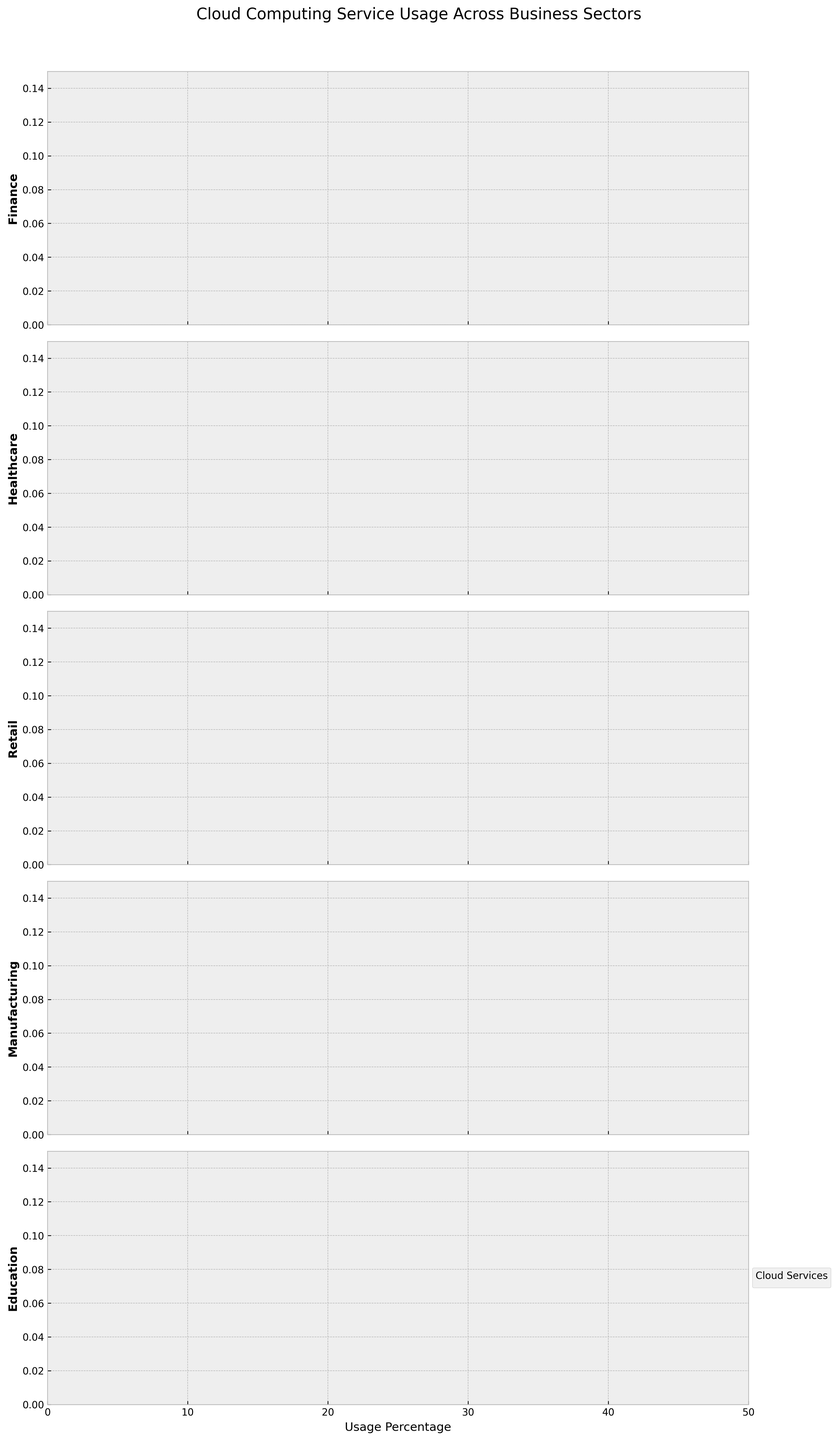What is the title of the figure? The title of the figure is written at the top, which provides an overview of what the figure is about. According to the data and code, the title should be "Cloud Computing Service Usage Across Business Sectors."
Answer: Cloud Computing Service Usage Across Business Sectors Which sector shows the highest usage percentage for Azure? By comparing the density plots across the sectors, the highest peak of Azure's usage percentage can be observed. The Education sector has the highest Azure usage at 35.6%.
Answer: Education Which cloud service has the lowest usage percentage in the Retail sector? By examining the density plots for the Retail sector, the cloud service with the lowest peak or distribution will be the least used. Oracle Cloud has the lowest usage percentage at 4.9%.
Answer: Oracle Cloud Is AWS usage generally higher in the Retail sector than in the Healthcare sector? Compare the density plots of AWS for both sectors. The peak and overall distribution for Retail are higher than Healthcare.
Answer: Yes What is the range of usage percentages displayed on the x-axis? The x-axis range can be determined by observing the limits set by the plots. From the provided code, the x-axis is limited from 0 to 50.
Answer: 0 to 50 Which business sector demonstrates the most balanced usage across all cloud services? A sector with evenly distributed usage percentages across different services would look more balanced. The Healthcare sector has close peaks for AWS (30.8%), Azure (32.1%), Google Cloud (15.6%), IBM Cloud (12.3%), and Oracle Cloud (9.2%).
Answer: Healthcare In which sector does Oracle Cloud have the highest usage percentage? Compare the density plots for Oracle Cloud across all sectors and identify the one with the highest peak. In the Healthcare sector, Oracle Cloud has its highest usage at 9.2%.
Answer: Healthcare Between Finance and Manufacturing sectors, which has a higher Google Cloud usage percentage? Compare the density plots for Google Cloud in the Finance and Manufacturing sectors. Finance has a usage percentage of 18.5%, while Manufacturing is 17.8%.
Answer: Finance 